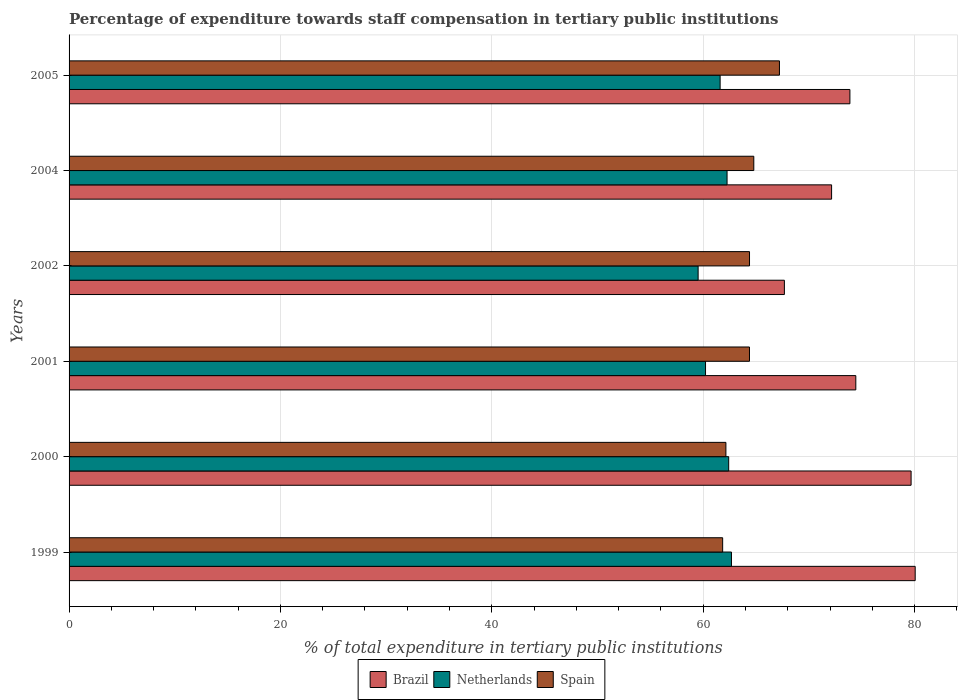How many different coloured bars are there?
Ensure brevity in your answer.  3. Are the number of bars on each tick of the Y-axis equal?
Provide a short and direct response. Yes. In how many cases, is the number of bars for a given year not equal to the number of legend labels?
Offer a terse response. 0. What is the percentage of expenditure towards staff compensation in Spain in 2005?
Offer a terse response. 67.22. Across all years, what is the maximum percentage of expenditure towards staff compensation in Netherlands?
Your response must be concise. 62.68. Across all years, what is the minimum percentage of expenditure towards staff compensation in Spain?
Provide a succinct answer. 61.84. What is the total percentage of expenditure towards staff compensation in Brazil in the graph?
Give a very brief answer. 447.89. What is the difference between the percentage of expenditure towards staff compensation in Brazil in 2000 and that in 2002?
Your answer should be compact. 11.99. What is the difference between the percentage of expenditure towards staff compensation in Brazil in 2000 and the percentage of expenditure towards staff compensation in Netherlands in 1999?
Provide a short and direct response. 17. What is the average percentage of expenditure towards staff compensation in Brazil per year?
Offer a terse response. 74.65. In the year 1999, what is the difference between the percentage of expenditure towards staff compensation in Spain and percentage of expenditure towards staff compensation in Netherlands?
Your response must be concise. -0.84. What is the ratio of the percentage of expenditure towards staff compensation in Spain in 1999 to that in 2004?
Make the answer very short. 0.95. Is the percentage of expenditure towards staff compensation in Netherlands in 1999 less than that in 2000?
Provide a succinct answer. No. What is the difference between the highest and the second highest percentage of expenditure towards staff compensation in Spain?
Offer a very short reply. 2.43. What is the difference between the highest and the lowest percentage of expenditure towards staff compensation in Netherlands?
Make the answer very short. 3.16. What does the 1st bar from the bottom in 2004 represents?
Your response must be concise. Brazil. Is it the case that in every year, the sum of the percentage of expenditure towards staff compensation in Brazil and percentage of expenditure towards staff compensation in Spain is greater than the percentage of expenditure towards staff compensation in Netherlands?
Offer a very short reply. Yes. Are all the bars in the graph horizontal?
Your answer should be very brief. Yes. What is the difference between two consecutive major ticks on the X-axis?
Keep it short and to the point. 20. Are the values on the major ticks of X-axis written in scientific E-notation?
Ensure brevity in your answer.  No. Does the graph contain grids?
Offer a very short reply. Yes. Where does the legend appear in the graph?
Your response must be concise. Bottom center. How are the legend labels stacked?
Your answer should be compact. Horizontal. What is the title of the graph?
Give a very brief answer. Percentage of expenditure towards staff compensation in tertiary public institutions. Does "New Caledonia" appear as one of the legend labels in the graph?
Keep it short and to the point. No. What is the label or title of the X-axis?
Your answer should be compact. % of total expenditure in tertiary public institutions. What is the label or title of the Y-axis?
Your response must be concise. Years. What is the % of total expenditure in tertiary public institutions of Brazil in 1999?
Keep it short and to the point. 80.06. What is the % of total expenditure in tertiary public institutions of Netherlands in 1999?
Provide a succinct answer. 62.68. What is the % of total expenditure in tertiary public institutions in Spain in 1999?
Provide a succinct answer. 61.84. What is the % of total expenditure in tertiary public institutions in Brazil in 2000?
Offer a terse response. 79.67. What is the % of total expenditure in tertiary public institutions of Netherlands in 2000?
Give a very brief answer. 62.41. What is the % of total expenditure in tertiary public institutions in Spain in 2000?
Your answer should be compact. 62.15. What is the % of total expenditure in tertiary public institutions of Brazil in 2001?
Offer a terse response. 74.44. What is the % of total expenditure in tertiary public institutions of Netherlands in 2001?
Provide a short and direct response. 60.22. What is the % of total expenditure in tertiary public institutions in Spain in 2001?
Ensure brevity in your answer.  64.38. What is the % of total expenditure in tertiary public institutions in Brazil in 2002?
Ensure brevity in your answer.  67.68. What is the % of total expenditure in tertiary public institutions in Netherlands in 2002?
Keep it short and to the point. 59.52. What is the % of total expenditure in tertiary public institutions of Spain in 2002?
Provide a succinct answer. 64.38. What is the % of total expenditure in tertiary public institutions in Brazil in 2004?
Make the answer very short. 72.15. What is the % of total expenditure in tertiary public institutions of Netherlands in 2004?
Your answer should be very brief. 62.26. What is the % of total expenditure in tertiary public institutions of Spain in 2004?
Provide a short and direct response. 64.79. What is the % of total expenditure in tertiary public institutions in Brazil in 2005?
Offer a terse response. 73.88. What is the % of total expenditure in tertiary public institutions in Netherlands in 2005?
Provide a short and direct response. 61.6. What is the % of total expenditure in tertiary public institutions in Spain in 2005?
Your answer should be very brief. 67.22. Across all years, what is the maximum % of total expenditure in tertiary public institutions of Brazil?
Offer a very short reply. 80.06. Across all years, what is the maximum % of total expenditure in tertiary public institutions of Netherlands?
Your answer should be very brief. 62.68. Across all years, what is the maximum % of total expenditure in tertiary public institutions in Spain?
Ensure brevity in your answer.  67.22. Across all years, what is the minimum % of total expenditure in tertiary public institutions of Brazil?
Make the answer very short. 67.68. Across all years, what is the minimum % of total expenditure in tertiary public institutions of Netherlands?
Your answer should be compact. 59.52. Across all years, what is the minimum % of total expenditure in tertiary public institutions of Spain?
Offer a terse response. 61.84. What is the total % of total expenditure in tertiary public institutions in Brazil in the graph?
Provide a succinct answer. 447.89. What is the total % of total expenditure in tertiary public institutions of Netherlands in the graph?
Provide a succinct answer. 368.69. What is the total % of total expenditure in tertiary public institutions of Spain in the graph?
Your response must be concise. 384.76. What is the difference between the % of total expenditure in tertiary public institutions of Brazil in 1999 and that in 2000?
Keep it short and to the point. 0.39. What is the difference between the % of total expenditure in tertiary public institutions of Netherlands in 1999 and that in 2000?
Give a very brief answer. 0.26. What is the difference between the % of total expenditure in tertiary public institutions of Spain in 1999 and that in 2000?
Your answer should be compact. -0.31. What is the difference between the % of total expenditure in tertiary public institutions in Brazil in 1999 and that in 2001?
Offer a terse response. 5.62. What is the difference between the % of total expenditure in tertiary public institutions in Netherlands in 1999 and that in 2001?
Provide a short and direct response. 2.46. What is the difference between the % of total expenditure in tertiary public institutions of Spain in 1999 and that in 2001?
Your answer should be very brief. -2.54. What is the difference between the % of total expenditure in tertiary public institutions of Brazil in 1999 and that in 2002?
Ensure brevity in your answer.  12.38. What is the difference between the % of total expenditure in tertiary public institutions in Netherlands in 1999 and that in 2002?
Provide a short and direct response. 3.16. What is the difference between the % of total expenditure in tertiary public institutions in Spain in 1999 and that in 2002?
Give a very brief answer. -2.54. What is the difference between the % of total expenditure in tertiary public institutions in Brazil in 1999 and that in 2004?
Offer a very short reply. 7.91. What is the difference between the % of total expenditure in tertiary public institutions in Netherlands in 1999 and that in 2004?
Make the answer very short. 0.42. What is the difference between the % of total expenditure in tertiary public institutions of Spain in 1999 and that in 2004?
Offer a terse response. -2.95. What is the difference between the % of total expenditure in tertiary public institutions in Brazil in 1999 and that in 2005?
Keep it short and to the point. 6.18. What is the difference between the % of total expenditure in tertiary public institutions in Netherlands in 1999 and that in 2005?
Provide a succinct answer. 1.07. What is the difference between the % of total expenditure in tertiary public institutions of Spain in 1999 and that in 2005?
Your response must be concise. -5.38. What is the difference between the % of total expenditure in tertiary public institutions of Brazil in 2000 and that in 2001?
Offer a very short reply. 5.23. What is the difference between the % of total expenditure in tertiary public institutions in Netherlands in 2000 and that in 2001?
Keep it short and to the point. 2.19. What is the difference between the % of total expenditure in tertiary public institutions in Spain in 2000 and that in 2001?
Your answer should be compact. -2.23. What is the difference between the % of total expenditure in tertiary public institutions of Brazil in 2000 and that in 2002?
Make the answer very short. 11.99. What is the difference between the % of total expenditure in tertiary public institutions in Netherlands in 2000 and that in 2002?
Your answer should be compact. 2.89. What is the difference between the % of total expenditure in tertiary public institutions of Spain in 2000 and that in 2002?
Offer a terse response. -2.23. What is the difference between the % of total expenditure in tertiary public institutions in Brazil in 2000 and that in 2004?
Ensure brevity in your answer.  7.52. What is the difference between the % of total expenditure in tertiary public institutions of Netherlands in 2000 and that in 2004?
Offer a terse response. 0.15. What is the difference between the % of total expenditure in tertiary public institutions in Spain in 2000 and that in 2004?
Your answer should be compact. -2.64. What is the difference between the % of total expenditure in tertiary public institutions of Brazil in 2000 and that in 2005?
Offer a terse response. 5.79. What is the difference between the % of total expenditure in tertiary public institutions in Netherlands in 2000 and that in 2005?
Your answer should be very brief. 0.81. What is the difference between the % of total expenditure in tertiary public institutions in Spain in 2000 and that in 2005?
Ensure brevity in your answer.  -5.07. What is the difference between the % of total expenditure in tertiary public institutions in Brazil in 2001 and that in 2002?
Give a very brief answer. 6.76. What is the difference between the % of total expenditure in tertiary public institutions of Netherlands in 2001 and that in 2002?
Provide a short and direct response. 0.7. What is the difference between the % of total expenditure in tertiary public institutions in Spain in 2001 and that in 2002?
Your answer should be very brief. -0. What is the difference between the % of total expenditure in tertiary public institutions of Brazil in 2001 and that in 2004?
Provide a succinct answer. 2.29. What is the difference between the % of total expenditure in tertiary public institutions of Netherlands in 2001 and that in 2004?
Keep it short and to the point. -2.04. What is the difference between the % of total expenditure in tertiary public institutions of Spain in 2001 and that in 2004?
Your response must be concise. -0.41. What is the difference between the % of total expenditure in tertiary public institutions in Brazil in 2001 and that in 2005?
Your response must be concise. 0.56. What is the difference between the % of total expenditure in tertiary public institutions in Netherlands in 2001 and that in 2005?
Ensure brevity in your answer.  -1.38. What is the difference between the % of total expenditure in tertiary public institutions in Spain in 2001 and that in 2005?
Your response must be concise. -2.84. What is the difference between the % of total expenditure in tertiary public institutions of Brazil in 2002 and that in 2004?
Offer a very short reply. -4.47. What is the difference between the % of total expenditure in tertiary public institutions in Netherlands in 2002 and that in 2004?
Keep it short and to the point. -2.74. What is the difference between the % of total expenditure in tertiary public institutions in Spain in 2002 and that in 2004?
Keep it short and to the point. -0.41. What is the difference between the % of total expenditure in tertiary public institutions in Brazil in 2002 and that in 2005?
Provide a succinct answer. -6.2. What is the difference between the % of total expenditure in tertiary public institutions in Netherlands in 2002 and that in 2005?
Offer a very short reply. -2.08. What is the difference between the % of total expenditure in tertiary public institutions in Spain in 2002 and that in 2005?
Your answer should be very brief. -2.83. What is the difference between the % of total expenditure in tertiary public institutions in Brazil in 2004 and that in 2005?
Provide a succinct answer. -1.73. What is the difference between the % of total expenditure in tertiary public institutions in Netherlands in 2004 and that in 2005?
Your answer should be compact. 0.66. What is the difference between the % of total expenditure in tertiary public institutions in Spain in 2004 and that in 2005?
Your answer should be compact. -2.43. What is the difference between the % of total expenditure in tertiary public institutions in Brazil in 1999 and the % of total expenditure in tertiary public institutions in Netherlands in 2000?
Ensure brevity in your answer.  17.65. What is the difference between the % of total expenditure in tertiary public institutions of Brazil in 1999 and the % of total expenditure in tertiary public institutions of Spain in 2000?
Offer a terse response. 17.91. What is the difference between the % of total expenditure in tertiary public institutions of Netherlands in 1999 and the % of total expenditure in tertiary public institutions of Spain in 2000?
Your response must be concise. 0.53. What is the difference between the % of total expenditure in tertiary public institutions in Brazil in 1999 and the % of total expenditure in tertiary public institutions in Netherlands in 2001?
Offer a terse response. 19.84. What is the difference between the % of total expenditure in tertiary public institutions of Brazil in 1999 and the % of total expenditure in tertiary public institutions of Spain in 2001?
Your response must be concise. 15.68. What is the difference between the % of total expenditure in tertiary public institutions in Netherlands in 1999 and the % of total expenditure in tertiary public institutions in Spain in 2001?
Provide a short and direct response. -1.7. What is the difference between the % of total expenditure in tertiary public institutions of Brazil in 1999 and the % of total expenditure in tertiary public institutions of Netherlands in 2002?
Offer a terse response. 20.54. What is the difference between the % of total expenditure in tertiary public institutions in Brazil in 1999 and the % of total expenditure in tertiary public institutions in Spain in 2002?
Keep it short and to the point. 15.68. What is the difference between the % of total expenditure in tertiary public institutions of Netherlands in 1999 and the % of total expenditure in tertiary public institutions of Spain in 2002?
Provide a succinct answer. -1.71. What is the difference between the % of total expenditure in tertiary public institutions of Brazil in 1999 and the % of total expenditure in tertiary public institutions of Netherlands in 2004?
Offer a terse response. 17.8. What is the difference between the % of total expenditure in tertiary public institutions in Brazil in 1999 and the % of total expenditure in tertiary public institutions in Spain in 2004?
Make the answer very short. 15.27. What is the difference between the % of total expenditure in tertiary public institutions in Netherlands in 1999 and the % of total expenditure in tertiary public institutions in Spain in 2004?
Keep it short and to the point. -2.11. What is the difference between the % of total expenditure in tertiary public institutions in Brazil in 1999 and the % of total expenditure in tertiary public institutions in Netherlands in 2005?
Make the answer very short. 18.46. What is the difference between the % of total expenditure in tertiary public institutions in Brazil in 1999 and the % of total expenditure in tertiary public institutions in Spain in 2005?
Give a very brief answer. 12.84. What is the difference between the % of total expenditure in tertiary public institutions in Netherlands in 1999 and the % of total expenditure in tertiary public institutions in Spain in 2005?
Provide a succinct answer. -4.54. What is the difference between the % of total expenditure in tertiary public institutions of Brazil in 2000 and the % of total expenditure in tertiary public institutions of Netherlands in 2001?
Offer a terse response. 19.45. What is the difference between the % of total expenditure in tertiary public institutions in Brazil in 2000 and the % of total expenditure in tertiary public institutions in Spain in 2001?
Make the answer very short. 15.29. What is the difference between the % of total expenditure in tertiary public institutions of Netherlands in 2000 and the % of total expenditure in tertiary public institutions of Spain in 2001?
Offer a very short reply. -1.97. What is the difference between the % of total expenditure in tertiary public institutions of Brazil in 2000 and the % of total expenditure in tertiary public institutions of Netherlands in 2002?
Your answer should be very brief. 20.15. What is the difference between the % of total expenditure in tertiary public institutions of Brazil in 2000 and the % of total expenditure in tertiary public institutions of Spain in 2002?
Your response must be concise. 15.29. What is the difference between the % of total expenditure in tertiary public institutions in Netherlands in 2000 and the % of total expenditure in tertiary public institutions in Spain in 2002?
Your answer should be very brief. -1.97. What is the difference between the % of total expenditure in tertiary public institutions in Brazil in 2000 and the % of total expenditure in tertiary public institutions in Netherlands in 2004?
Keep it short and to the point. 17.41. What is the difference between the % of total expenditure in tertiary public institutions of Brazil in 2000 and the % of total expenditure in tertiary public institutions of Spain in 2004?
Offer a very short reply. 14.88. What is the difference between the % of total expenditure in tertiary public institutions of Netherlands in 2000 and the % of total expenditure in tertiary public institutions of Spain in 2004?
Your answer should be very brief. -2.38. What is the difference between the % of total expenditure in tertiary public institutions in Brazil in 2000 and the % of total expenditure in tertiary public institutions in Netherlands in 2005?
Ensure brevity in your answer.  18.07. What is the difference between the % of total expenditure in tertiary public institutions in Brazil in 2000 and the % of total expenditure in tertiary public institutions in Spain in 2005?
Keep it short and to the point. 12.46. What is the difference between the % of total expenditure in tertiary public institutions of Netherlands in 2000 and the % of total expenditure in tertiary public institutions of Spain in 2005?
Provide a short and direct response. -4.8. What is the difference between the % of total expenditure in tertiary public institutions in Brazil in 2001 and the % of total expenditure in tertiary public institutions in Netherlands in 2002?
Your response must be concise. 14.92. What is the difference between the % of total expenditure in tertiary public institutions of Brazil in 2001 and the % of total expenditure in tertiary public institutions of Spain in 2002?
Provide a succinct answer. 10.06. What is the difference between the % of total expenditure in tertiary public institutions in Netherlands in 2001 and the % of total expenditure in tertiary public institutions in Spain in 2002?
Make the answer very short. -4.16. What is the difference between the % of total expenditure in tertiary public institutions of Brazil in 2001 and the % of total expenditure in tertiary public institutions of Netherlands in 2004?
Your response must be concise. 12.18. What is the difference between the % of total expenditure in tertiary public institutions in Brazil in 2001 and the % of total expenditure in tertiary public institutions in Spain in 2004?
Your answer should be compact. 9.65. What is the difference between the % of total expenditure in tertiary public institutions in Netherlands in 2001 and the % of total expenditure in tertiary public institutions in Spain in 2004?
Your answer should be compact. -4.57. What is the difference between the % of total expenditure in tertiary public institutions in Brazil in 2001 and the % of total expenditure in tertiary public institutions in Netherlands in 2005?
Give a very brief answer. 12.84. What is the difference between the % of total expenditure in tertiary public institutions in Brazil in 2001 and the % of total expenditure in tertiary public institutions in Spain in 2005?
Your response must be concise. 7.22. What is the difference between the % of total expenditure in tertiary public institutions in Netherlands in 2001 and the % of total expenditure in tertiary public institutions in Spain in 2005?
Your response must be concise. -7. What is the difference between the % of total expenditure in tertiary public institutions in Brazil in 2002 and the % of total expenditure in tertiary public institutions in Netherlands in 2004?
Your answer should be very brief. 5.42. What is the difference between the % of total expenditure in tertiary public institutions of Brazil in 2002 and the % of total expenditure in tertiary public institutions of Spain in 2004?
Offer a terse response. 2.89. What is the difference between the % of total expenditure in tertiary public institutions in Netherlands in 2002 and the % of total expenditure in tertiary public institutions in Spain in 2004?
Keep it short and to the point. -5.27. What is the difference between the % of total expenditure in tertiary public institutions in Brazil in 2002 and the % of total expenditure in tertiary public institutions in Netherlands in 2005?
Give a very brief answer. 6.08. What is the difference between the % of total expenditure in tertiary public institutions in Brazil in 2002 and the % of total expenditure in tertiary public institutions in Spain in 2005?
Provide a succinct answer. 0.47. What is the difference between the % of total expenditure in tertiary public institutions of Netherlands in 2002 and the % of total expenditure in tertiary public institutions of Spain in 2005?
Offer a very short reply. -7.7. What is the difference between the % of total expenditure in tertiary public institutions in Brazil in 2004 and the % of total expenditure in tertiary public institutions in Netherlands in 2005?
Offer a very short reply. 10.55. What is the difference between the % of total expenditure in tertiary public institutions in Brazil in 2004 and the % of total expenditure in tertiary public institutions in Spain in 2005?
Your answer should be compact. 4.93. What is the difference between the % of total expenditure in tertiary public institutions in Netherlands in 2004 and the % of total expenditure in tertiary public institutions in Spain in 2005?
Provide a short and direct response. -4.96. What is the average % of total expenditure in tertiary public institutions of Brazil per year?
Your answer should be very brief. 74.65. What is the average % of total expenditure in tertiary public institutions in Netherlands per year?
Make the answer very short. 61.45. What is the average % of total expenditure in tertiary public institutions in Spain per year?
Offer a terse response. 64.13. In the year 1999, what is the difference between the % of total expenditure in tertiary public institutions of Brazil and % of total expenditure in tertiary public institutions of Netherlands?
Ensure brevity in your answer.  17.38. In the year 1999, what is the difference between the % of total expenditure in tertiary public institutions in Brazil and % of total expenditure in tertiary public institutions in Spain?
Offer a terse response. 18.22. In the year 1999, what is the difference between the % of total expenditure in tertiary public institutions of Netherlands and % of total expenditure in tertiary public institutions of Spain?
Your answer should be very brief. 0.84. In the year 2000, what is the difference between the % of total expenditure in tertiary public institutions of Brazil and % of total expenditure in tertiary public institutions of Netherlands?
Your response must be concise. 17.26. In the year 2000, what is the difference between the % of total expenditure in tertiary public institutions of Brazil and % of total expenditure in tertiary public institutions of Spain?
Make the answer very short. 17.52. In the year 2000, what is the difference between the % of total expenditure in tertiary public institutions of Netherlands and % of total expenditure in tertiary public institutions of Spain?
Keep it short and to the point. 0.26. In the year 2001, what is the difference between the % of total expenditure in tertiary public institutions of Brazil and % of total expenditure in tertiary public institutions of Netherlands?
Your response must be concise. 14.22. In the year 2001, what is the difference between the % of total expenditure in tertiary public institutions of Brazil and % of total expenditure in tertiary public institutions of Spain?
Your answer should be compact. 10.06. In the year 2001, what is the difference between the % of total expenditure in tertiary public institutions of Netherlands and % of total expenditure in tertiary public institutions of Spain?
Your response must be concise. -4.16. In the year 2002, what is the difference between the % of total expenditure in tertiary public institutions of Brazil and % of total expenditure in tertiary public institutions of Netherlands?
Your answer should be very brief. 8.16. In the year 2002, what is the difference between the % of total expenditure in tertiary public institutions of Brazil and % of total expenditure in tertiary public institutions of Spain?
Your response must be concise. 3.3. In the year 2002, what is the difference between the % of total expenditure in tertiary public institutions in Netherlands and % of total expenditure in tertiary public institutions in Spain?
Offer a very short reply. -4.86. In the year 2004, what is the difference between the % of total expenditure in tertiary public institutions in Brazil and % of total expenditure in tertiary public institutions in Netherlands?
Your response must be concise. 9.89. In the year 2004, what is the difference between the % of total expenditure in tertiary public institutions of Brazil and % of total expenditure in tertiary public institutions of Spain?
Your response must be concise. 7.36. In the year 2004, what is the difference between the % of total expenditure in tertiary public institutions of Netherlands and % of total expenditure in tertiary public institutions of Spain?
Offer a very short reply. -2.53. In the year 2005, what is the difference between the % of total expenditure in tertiary public institutions in Brazil and % of total expenditure in tertiary public institutions in Netherlands?
Your response must be concise. 12.28. In the year 2005, what is the difference between the % of total expenditure in tertiary public institutions in Brazil and % of total expenditure in tertiary public institutions in Spain?
Keep it short and to the point. 6.67. In the year 2005, what is the difference between the % of total expenditure in tertiary public institutions in Netherlands and % of total expenditure in tertiary public institutions in Spain?
Provide a succinct answer. -5.61. What is the ratio of the % of total expenditure in tertiary public institutions in Brazil in 1999 to that in 2000?
Ensure brevity in your answer.  1. What is the ratio of the % of total expenditure in tertiary public institutions in Spain in 1999 to that in 2000?
Provide a succinct answer. 0.99. What is the ratio of the % of total expenditure in tertiary public institutions in Brazil in 1999 to that in 2001?
Your answer should be compact. 1.08. What is the ratio of the % of total expenditure in tertiary public institutions of Netherlands in 1999 to that in 2001?
Your response must be concise. 1.04. What is the ratio of the % of total expenditure in tertiary public institutions in Spain in 1999 to that in 2001?
Your answer should be compact. 0.96. What is the ratio of the % of total expenditure in tertiary public institutions in Brazil in 1999 to that in 2002?
Make the answer very short. 1.18. What is the ratio of the % of total expenditure in tertiary public institutions in Netherlands in 1999 to that in 2002?
Your answer should be very brief. 1.05. What is the ratio of the % of total expenditure in tertiary public institutions in Spain in 1999 to that in 2002?
Keep it short and to the point. 0.96. What is the ratio of the % of total expenditure in tertiary public institutions of Brazil in 1999 to that in 2004?
Provide a short and direct response. 1.11. What is the ratio of the % of total expenditure in tertiary public institutions in Spain in 1999 to that in 2004?
Provide a short and direct response. 0.95. What is the ratio of the % of total expenditure in tertiary public institutions in Brazil in 1999 to that in 2005?
Offer a terse response. 1.08. What is the ratio of the % of total expenditure in tertiary public institutions in Netherlands in 1999 to that in 2005?
Provide a short and direct response. 1.02. What is the ratio of the % of total expenditure in tertiary public institutions of Spain in 1999 to that in 2005?
Your answer should be very brief. 0.92. What is the ratio of the % of total expenditure in tertiary public institutions of Brazil in 2000 to that in 2001?
Ensure brevity in your answer.  1.07. What is the ratio of the % of total expenditure in tertiary public institutions of Netherlands in 2000 to that in 2001?
Your response must be concise. 1.04. What is the ratio of the % of total expenditure in tertiary public institutions in Spain in 2000 to that in 2001?
Provide a succinct answer. 0.97. What is the ratio of the % of total expenditure in tertiary public institutions of Brazil in 2000 to that in 2002?
Your answer should be very brief. 1.18. What is the ratio of the % of total expenditure in tertiary public institutions in Netherlands in 2000 to that in 2002?
Your answer should be compact. 1.05. What is the ratio of the % of total expenditure in tertiary public institutions of Spain in 2000 to that in 2002?
Your response must be concise. 0.97. What is the ratio of the % of total expenditure in tertiary public institutions of Brazil in 2000 to that in 2004?
Your response must be concise. 1.1. What is the ratio of the % of total expenditure in tertiary public institutions in Netherlands in 2000 to that in 2004?
Offer a very short reply. 1. What is the ratio of the % of total expenditure in tertiary public institutions in Spain in 2000 to that in 2004?
Offer a very short reply. 0.96. What is the ratio of the % of total expenditure in tertiary public institutions of Brazil in 2000 to that in 2005?
Ensure brevity in your answer.  1.08. What is the ratio of the % of total expenditure in tertiary public institutions of Netherlands in 2000 to that in 2005?
Ensure brevity in your answer.  1.01. What is the ratio of the % of total expenditure in tertiary public institutions in Spain in 2000 to that in 2005?
Make the answer very short. 0.92. What is the ratio of the % of total expenditure in tertiary public institutions in Brazil in 2001 to that in 2002?
Make the answer very short. 1.1. What is the ratio of the % of total expenditure in tertiary public institutions of Netherlands in 2001 to that in 2002?
Ensure brevity in your answer.  1.01. What is the ratio of the % of total expenditure in tertiary public institutions in Brazil in 2001 to that in 2004?
Your response must be concise. 1.03. What is the ratio of the % of total expenditure in tertiary public institutions of Netherlands in 2001 to that in 2004?
Offer a terse response. 0.97. What is the ratio of the % of total expenditure in tertiary public institutions of Spain in 2001 to that in 2004?
Ensure brevity in your answer.  0.99. What is the ratio of the % of total expenditure in tertiary public institutions of Brazil in 2001 to that in 2005?
Your answer should be compact. 1.01. What is the ratio of the % of total expenditure in tertiary public institutions in Netherlands in 2001 to that in 2005?
Offer a very short reply. 0.98. What is the ratio of the % of total expenditure in tertiary public institutions in Spain in 2001 to that in 2005?
Keep it short and to the point. 0.96. What is the ratio of the % of total expenditure in tertiary public institutions of Brazil in 2002 to that in 2004?
Provide a short and direct response. 0.94. What is the ratio of the % of total expenditure in tertiary public institutions in Netherlands in 2002 to that in 2004?
Your response must be concise. 0.96. What is the ratio of the % of total expenditure in tertiary public institutions of Spain in 2002 to that in 2004?
Ensure brevity in your answer.  0.99. What is the ratio of the % of total expenditure in tertiary public institutions of Brazil in 2002 to that in 2005?
Make the answer very short. 0.92. What is the ratio of the % of total expenditure in tertiary public institutions of Netherlands in 2002 to that in 2005?
Your answer should be very brief. 0.97. What is the ratio of the % of total expenditure in tertiary public institutions of Spain in 2002 to that in 2005?
Make the answer very short. 0.96. What is the ratio of the % of total expenditure in tertiary public institutions of Brazil in 2004 to that in 2005?
Offer a very short reply. 0.98. What is the ratio of the % of total expenditure in tertiary public institutions in Netherlands in 2004 to that in 2005?
Provide a short and direct response. 1.01. What is the ratio of the % of total expenditure in tertiary public institutions in Spain in 2004 to that in 2005?
Ensure brevity in your answer.  0.96. What is the difference between the highest and the second highest % of total expenditure in tertiary public institutions of Brazil?
Your response must be concise. 0.39. What is the difference between the highest and the second highest % of total expenditure in tertiary public institutions in Netherlands?
Provide a succinct answer. 0.26. What is the difference between the highest and the second highest % of total expenditure in tertiary public institutions of Spain?
Make the answer very short. 2.43. What is the difference between the highest and the lowest % of total expenditure in tertiary public institutions of Brazil?
Give a very brief answer. 12.38. What is the difference between the highest and the lowest % of total expenditure in tertiary public institutions in Netherlands?
Give a very brief answer. 3.16. What is the difference between the highest and the lowest % of total expenditure in tertiary public institutions of Spain?
Your answer should be compact. 5.38. 